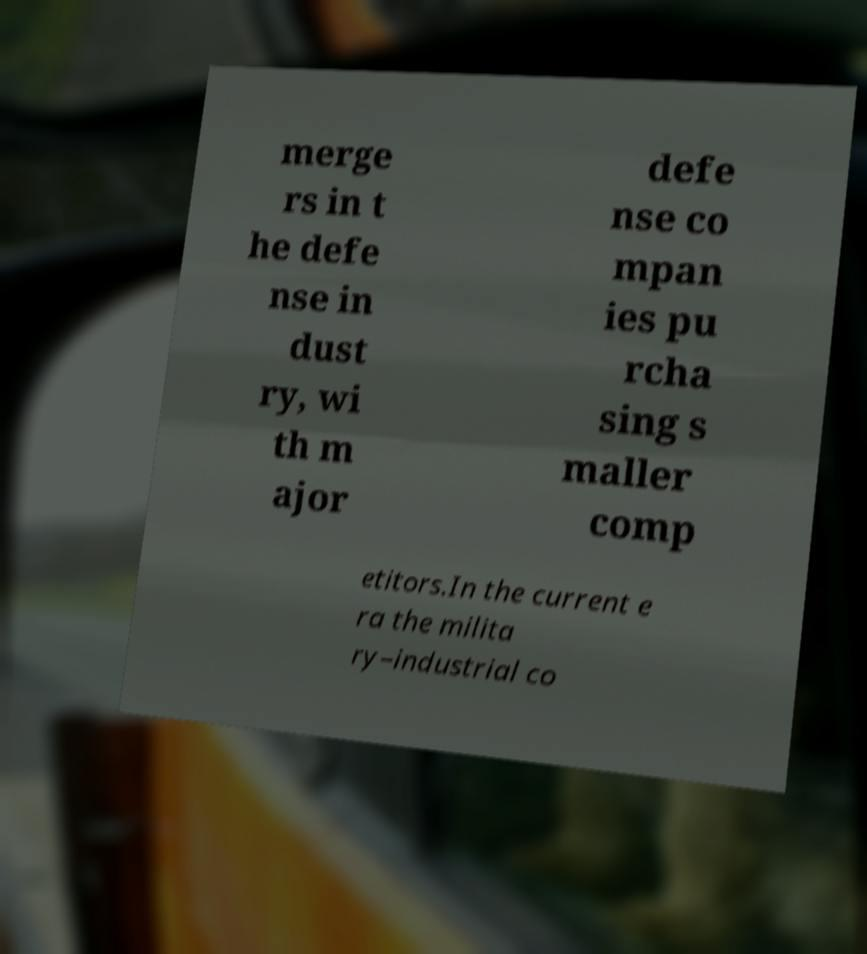Could you extract and type out the text from this image? merge rs in t he defe nse in dust ry, wi th m ajor defe nse co mpan ies pu rcha sing s maller comp etitors.In the current e ra the milita ry–industrial co 